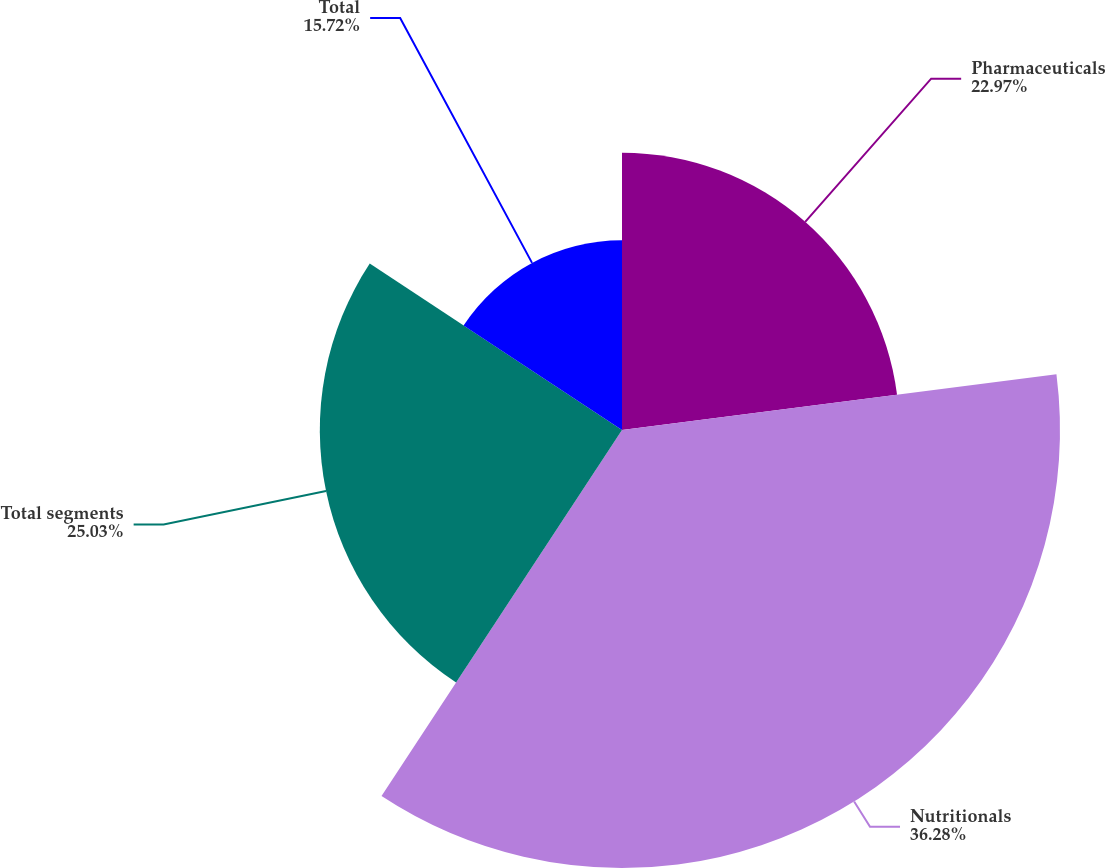<chart> <loc_0><loc_0><loc_500><loc_500><pie_chart><fcel>Pharmaceuticals<fcel>Nutritionals<fcel>Total segments<fcel>Total<nl><fcel>22.97%<fcel>36.28%<fcel>25.03%<fcel>15.72%<nl></chart> 